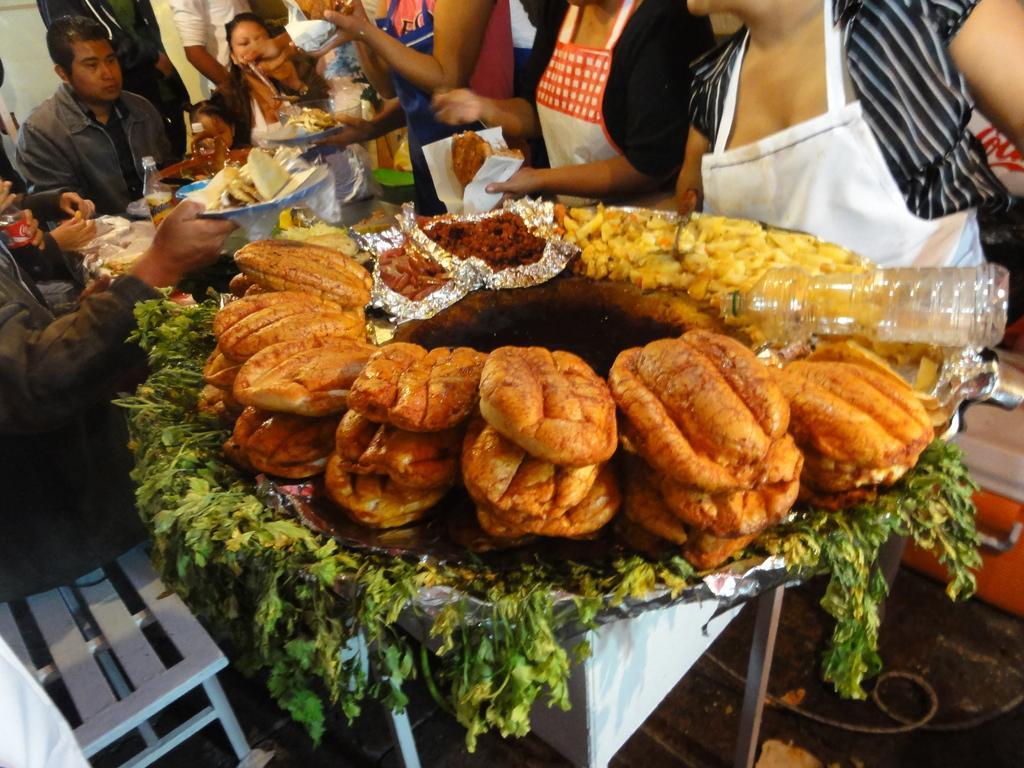Please provide a concise description of this image. In this image I can see a group of people are standing on the road side are holding plates in their hand and a metal stand on which leafy vegetables and food items are there. At the bottom I can see a bench and so on. This image is taken may be on the street. 